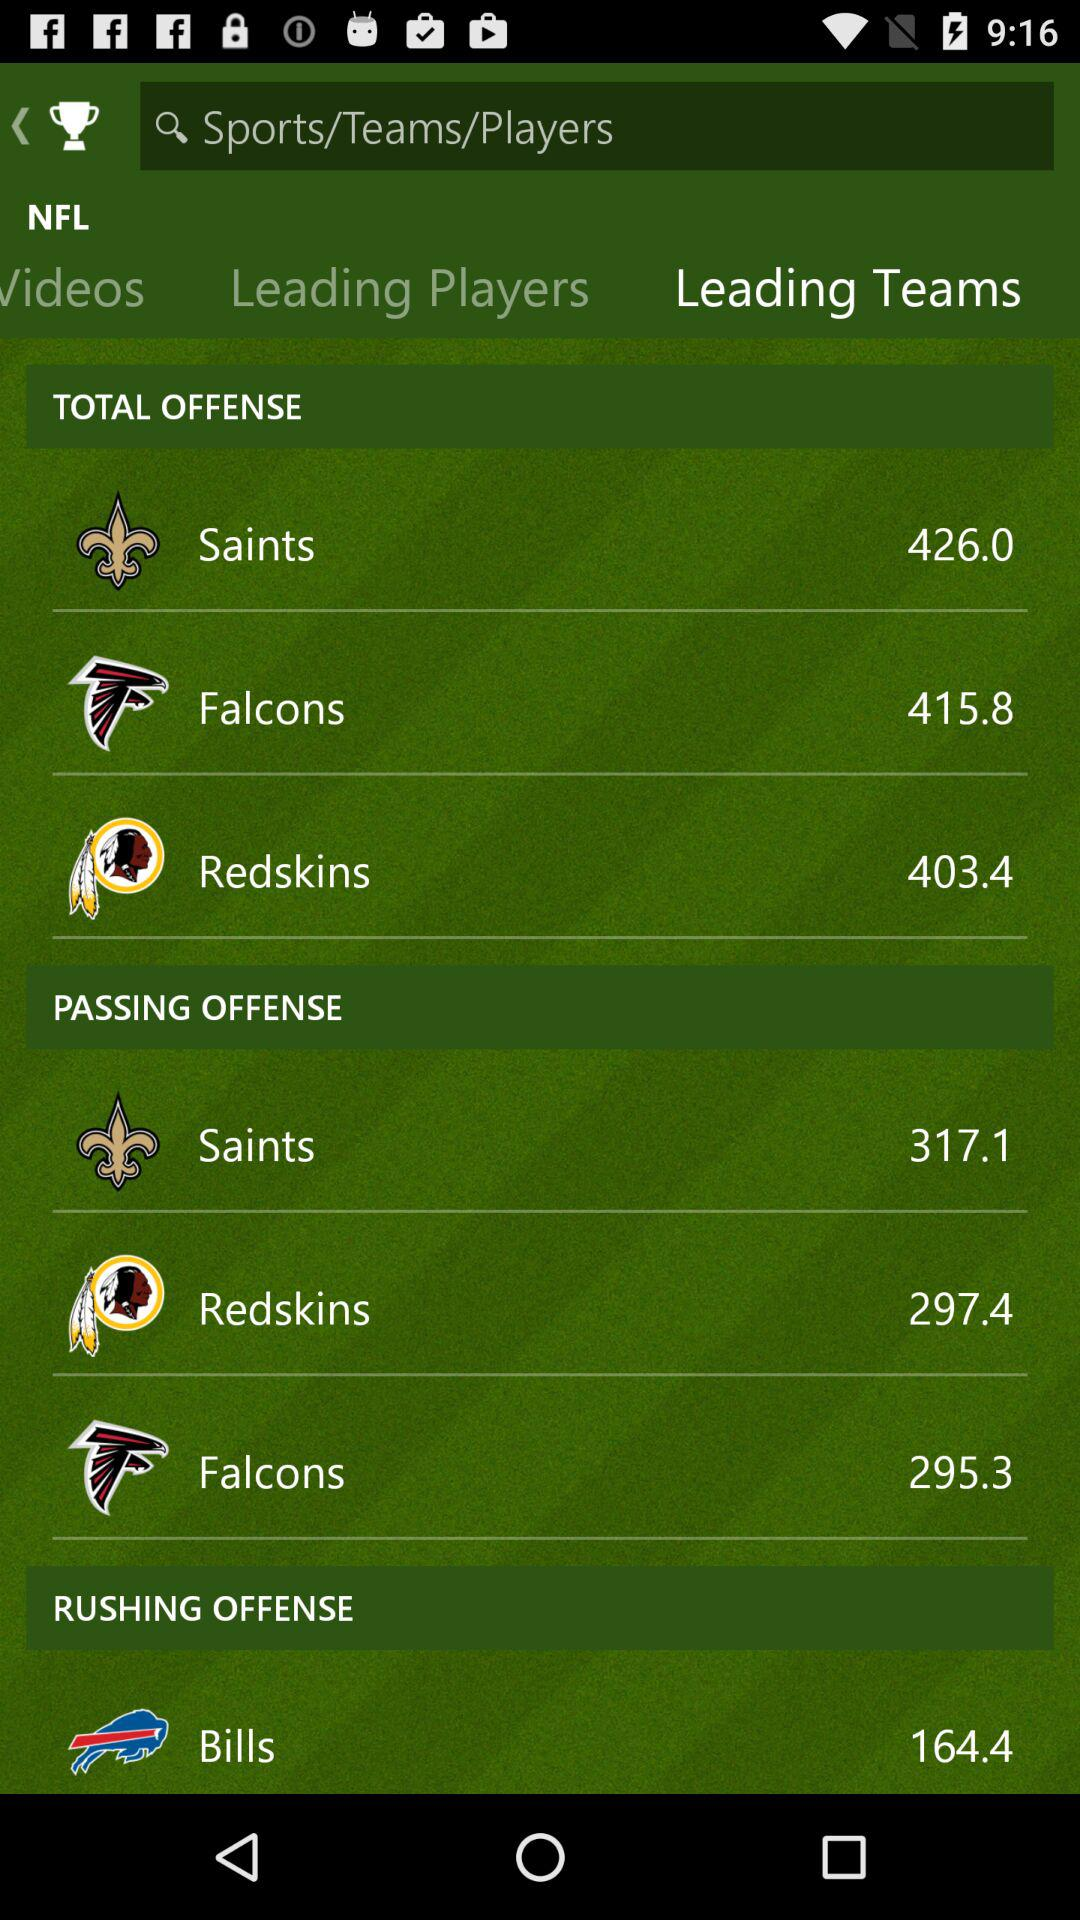How many passing offenses are committed by the Falcons? The passing offenses committed by the Falcons is 295.3. 